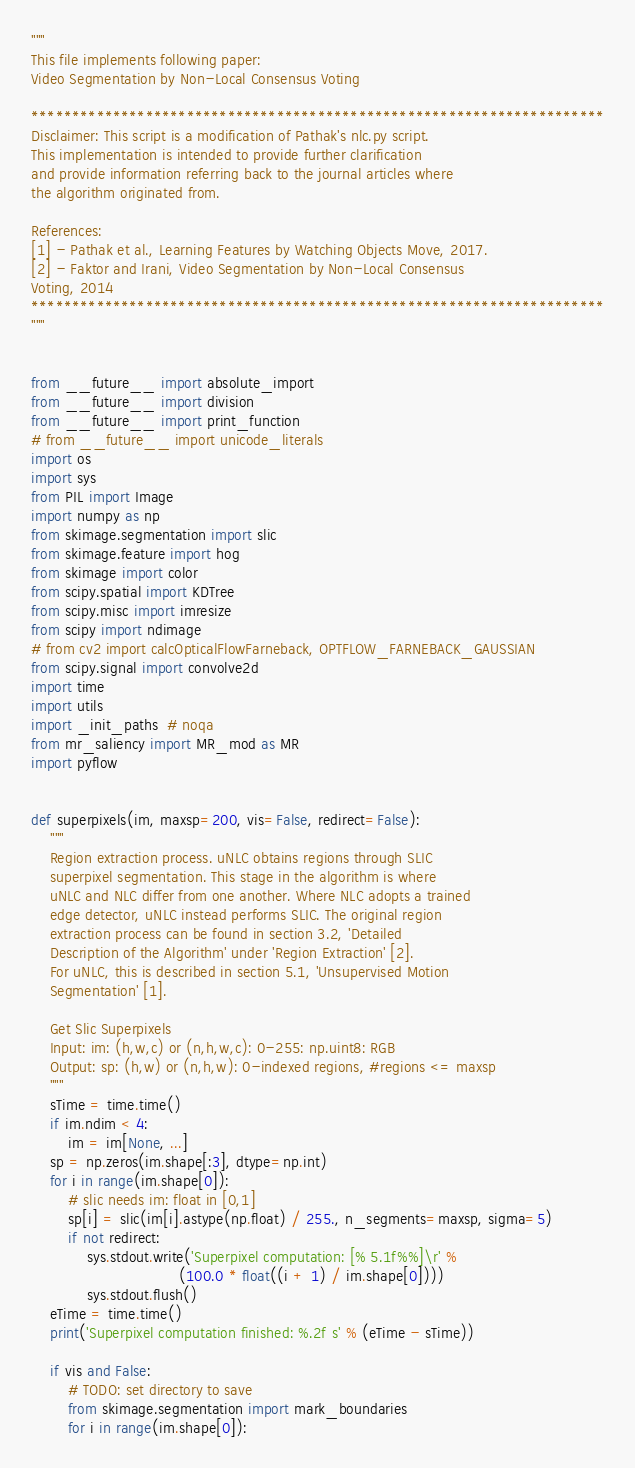<code> <loc_0><loc_0><loc_500><loc_500><_Python_>"""
This file implements following paper:
Video Segmentation by Non-Local Consensus Voting

**********************************************************************
Disclaimer: This script is a modification of Pathak's nlc.py script.
This implementation is intended to provide further clarification 
and provide information referring back to the journal articles where 
the algorithm originated from.

References: 
[1] - Pathak et al., Learning Features by Watching Objects Move, 2017.
[2] - Faktor and Irani, Video Segmentation by Non-Local Consensus 
Voting, 2014
**********************************************************************
"""


from __future__ import absolute_import
from __future__ import division
from __future__ import print_function
# from __future__ import unicode_literals
import os
import sys
from PIL import Image
import numpy as np
from skimage.segmentation import slic
from skimage.feature import hog
from skimage import color
from scipy.spatial import KDTree
from scipy.misc import imresize
from scipy import ndimage
# from cv2 import calcOpticalFlowFarneback, OPTFLOW_FARNEBACK_GAUSSIAN
from scipy.signal import convolve2d
import time
import utils
import _init_paths  # noqa
from mr_saliency import MR_mod as MR
import pyflow


def superpixels(im, maxsp=200, vis=False, redirect=False):
    """
    Region extraction process. uNLC obtains regions through SLIC 
    superpixel segmentation. This stage in the algorithm is where 
    uNLC and NLC differ from one another. Where NLC adopts a trained 
    edge detector, uNLC instead performs SLIC. The original region 
    extraction process can be found in section 3.2, 'Detailed 
    Description of the Algorithm' under 'Region Extraction' [2]. 
    For uNLC, this is described in section 5.1, 'Unsupervised Motion 
    Segmentation' [1].

    Get Slic Superpixels
    Input: im: (h,w,c) or (n,h,w,c): 0-255: np.uint8: RGB
    Output: sp: (h,w) or (n,h,w): 0-indexed regions, #regions <= maxsp
    """
    sTime = time.time()
    if im.ndim < 4:
        im = im[None, ...]
    sp = np.zeros(im.shape[:3], dtype=np.int)
    for i in range(im.shape[0]):
        # slic needs im: float in [0,1]
        sp[i] = slic(im[i].astype(np.float) / 255., n_segments=maxsp, sigma=5)
        if not redirect:
            sys.stdout.write('Superpixel computation: [% 5.1f%%]\r' %
                                (100.0 * float((i + 1) / im.shape[0])))
            sys.stdout.flush()
    eTime = time.time()
    print('Superpixel computation finished: %.2f s' % (eTime - sTime))

    if vis and False:
        # TODO: set directory to save
        from skimage.segmentation import mark_boundaries
        for i in range(im.shape[0]):</code> 